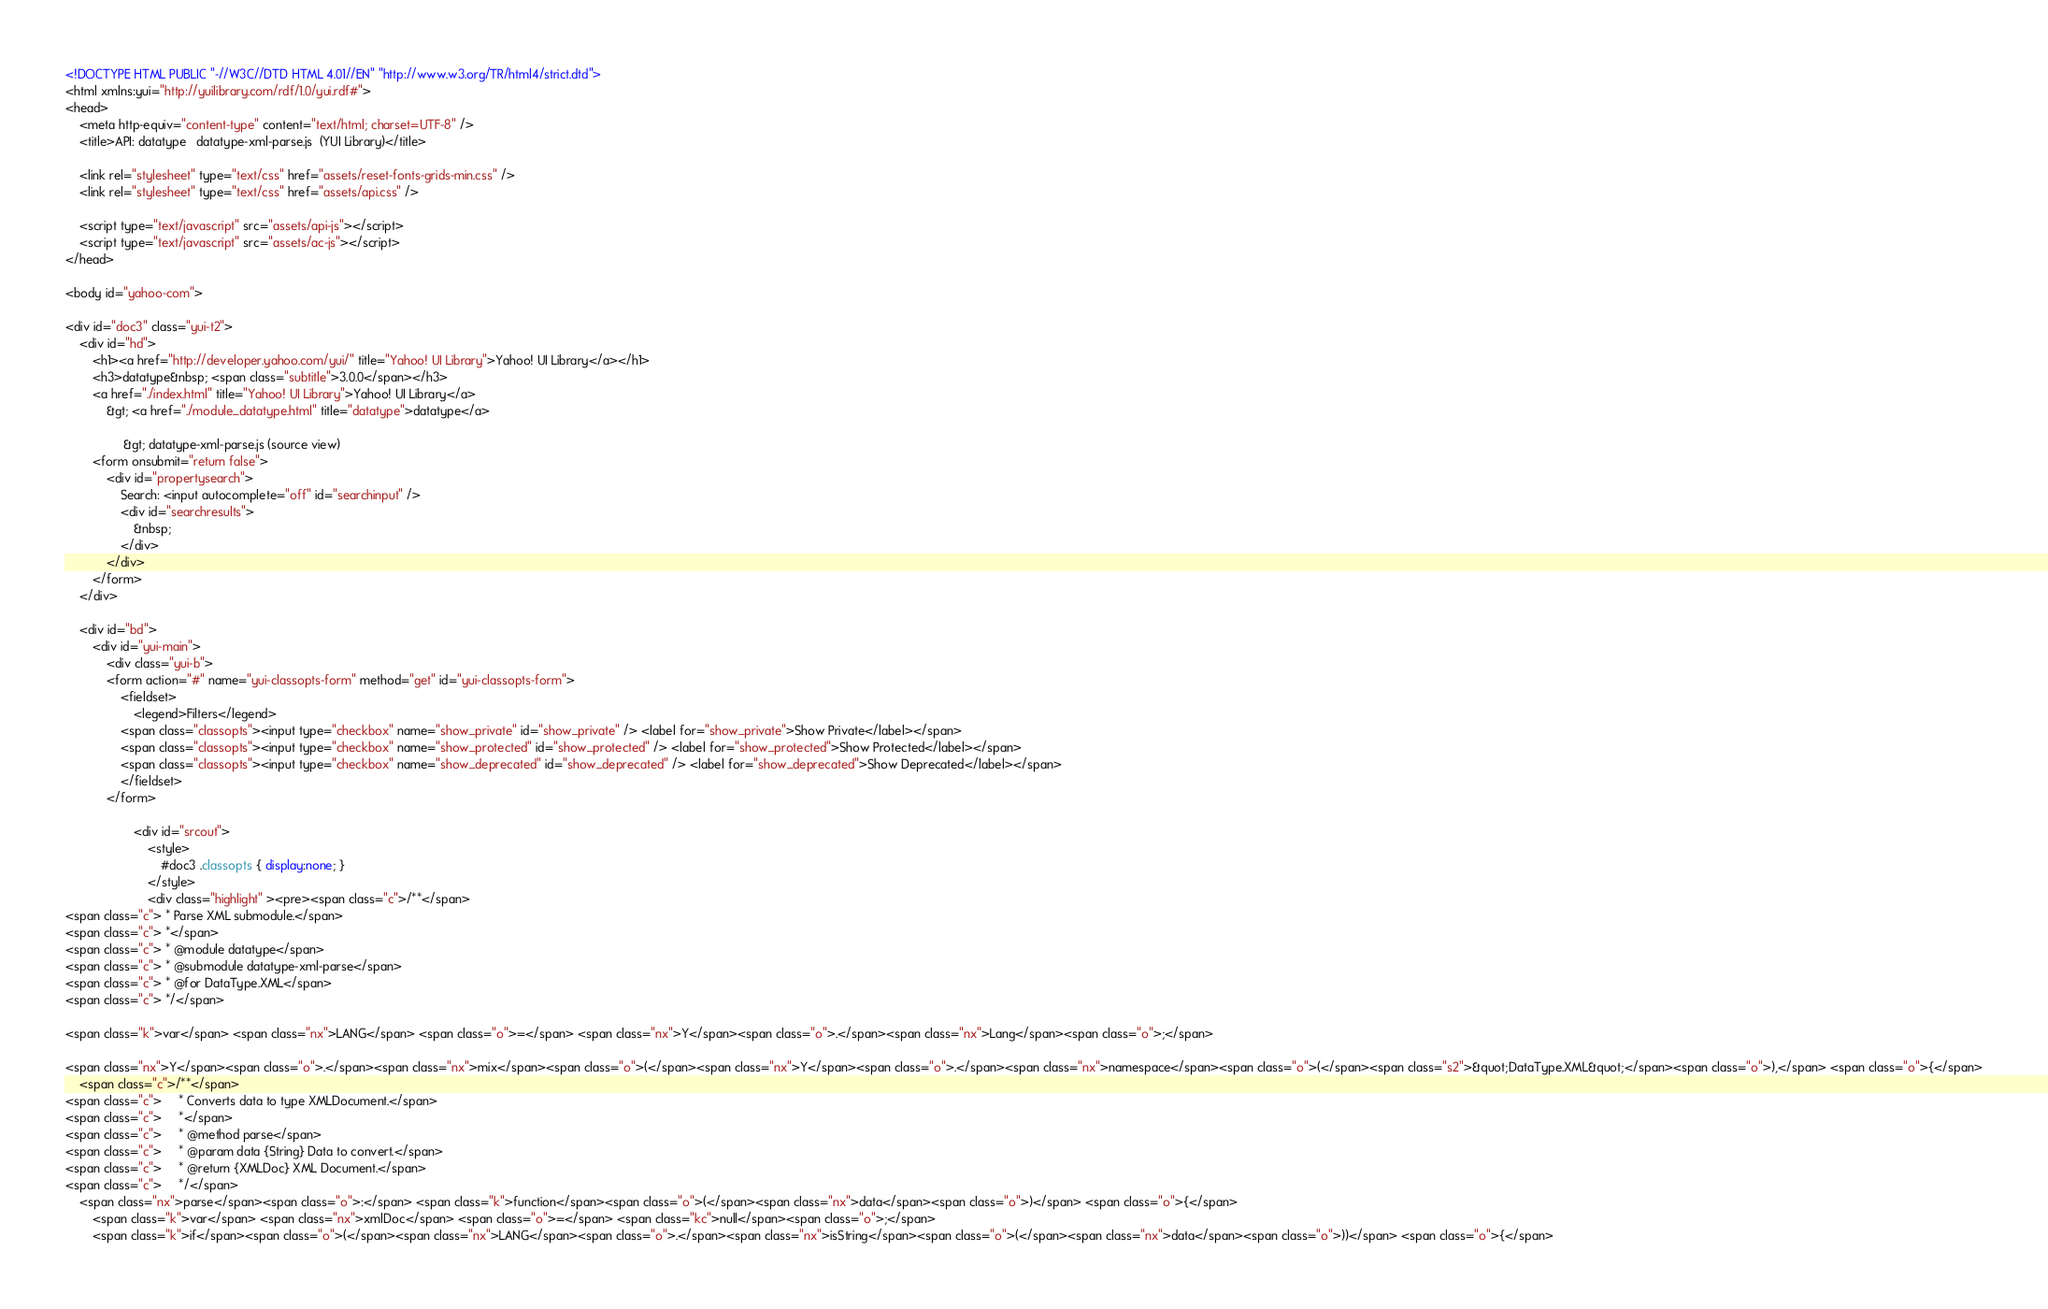<code> <loc_0><loc_0><loc_500><loc_500><_HTML_><!DOCTYPE HTML PUBLIC "-//W3C//DTD HTML 4.01//EN" "http://www.w3.org/TR/html4/strict.dtd">
<html xmlns:yui="http://yuilibrary.com/rdf/1.0/yui.rdf#">
<head>
    <meta http-equiv="content-type" content="text/html; charset=UTF-8" />
	<title>API: datatype   datatype-xml-parse.js  (YUI Library)</title>

	<link rel="stylesheet" type="text/css" href="assets/reset-fonts-grids-min.css" />
	<link rel="stylesheet" type="text/css" href="assets/api.css" />

    <script type="text/javascript" src="assets/api-js"></script>
    <script type="text/javascript" src="assets/ac-js"></script>
</head>

<body id="yahoo-com">

<div id="doc3" class="yui-t2">
	<div id="hd">
        <h1><a href="http://developer.yahoo.com/yui/" title="Yahoo! UI Library">Yahoo! UI Library</a></h1>
        <h3>datatype&nbsp; <span class="subtitle">3.0.0</span></h3>
        <a href="./index.html" title="Yahoo! UI Library">Yahoo! UI Library</a> 
            &gt; <a href="./module_datatype.html" title="datatype">datatype</a>
                
                 &gt; datatype-xml-parse.js (source view) 
        <form onsubmit="return false">
            <div id="propertysearch">
                Search: <input autocomplete="off" id="searchinput" />
                <div id="searchresults">
                    &nbsp;
                </div>
            </div>
        </form>
	</div>

	<div id="bd">
		<div id="yui-main">
			<div class="yui-b">
            <form action="#" name="yui-classopts-form" method="get" id="yui-classopts-form">
                <fieldset>
                    <legend>Filters</legend>
                <span class="classopts"><input type="checkbox" name="show_private" id="show_private" /> <label for="show_private">Show Private</label></span>
                <span class="classopts"><input type="checkbox" name="show_protected" id="show_protected" /> <label for="show_protected">Show Protected</label></span>
                <span class="classopts"><input type="checkbox" name="show_deprecated" id="show_deprecated" /> <label for="show_deprecated">Show Deprecated</label></span>
                </fieldset>
            </form>

                    <div id="srcout">
                        <style>
                            #doc3 .classopts { display:none; }
                        </style>
                        <div class="highlight" ><pre><span class="c">/**</span>
<span class="c"> * Parse XML submodule.</span>
<span class="c"> *</span>
<span class="c"> * @module datatype</span>
<span class="c"> * @submodule datatype-xml-parse</span>
<span class="c"> * @for DataType.XML</span>
<span class="c"> */</span>

<span class="k">var</span> <span class="nx">LANG</span> <span class="o">=</span> <span class="nx">Y</span><span class="o">.</span><span class="nx">Lang</span><span class="o">;</span>

<span class="nx">Y</span><span class="o">.</span><span class="nx">mix</span><span class="o">(</span><span class="nx">Y</span><span class="o">.</span><span class="nx">namespace</span><span class="o">(</span><span class="s2">&quot;DataType.XML&quot;</span><span class="o">),</span> <span class="o">{</span>
    <span class="c">/**</span>
<span class="c">     * Converts data to type XMLDocument.</span>
<span class="c">     *</span>
<span class="c">     * @method parse</span>
<span class="c">     * @param data {String} Data to convert.</span>
<span class="c">     * @return {XMLDoc} XML Document.</span>
<span class="c">     */</span>
    <span class="nx">parse</span><span class="o">:</span> <span class="k">function</span><span class="o">(</span><span class="nx">data</span><span class="o">)</span> <span class="o">{</span>
        <span class="k">var</span> <span class="nx">xmlDoc</span> <span class="o">=</span> <span class="kc">null</span><span class="o">;</span>
        <span class="k">if</span><span class="o">(</span><span class="nx">LANG</span><span class="o">.</span><span class="nx">isString</span><span class="o">(</span><span class="nx">data</span><span class="o">))</span> <span class="o">{</span></code> 